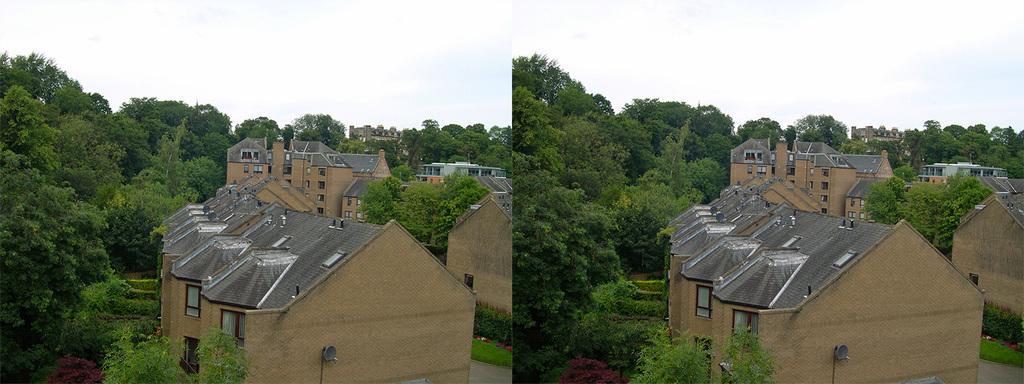How would you summarize this image in a sentence or two? In this picture we can see an image which is a collage. These are the houses in the middle. And there are many trees. And on the background there is a sky. 